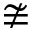<formula> <loc_0><loc_0><loc_500><loc_500>\ncong</formula> 